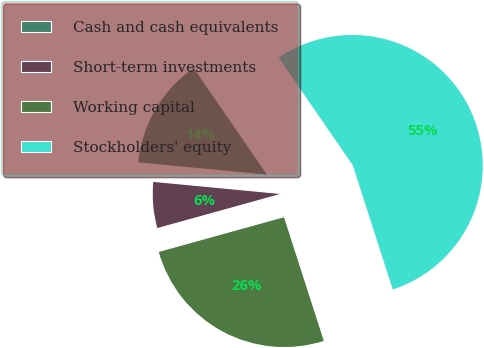<chart> <loc_0><loc_0><loc_500><loc_500><pie_chart><fcel>Cash and cash equivalents<fcel>Short-term investments<fcel>Working capital<fcel>Stockholders' equity<nl><fcel>13.89%<fcel>5.82%<fcel>25.65%<fcel>54.64%<nl></chart> 